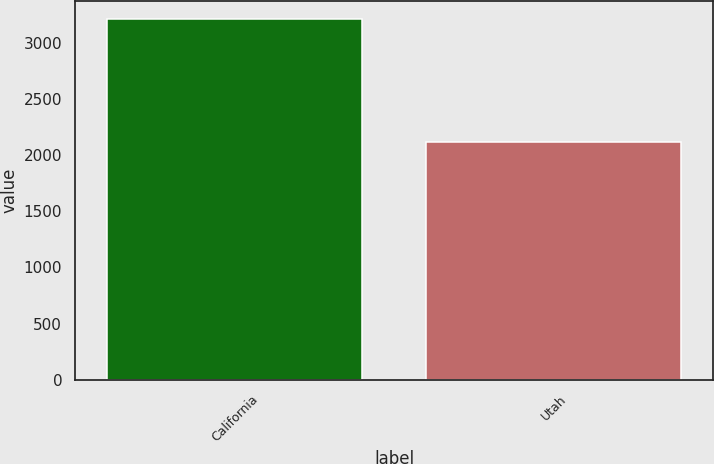<chart> <loc_0><loc_0><loc_500><loc_500><bar_chart><fcel>California<fcel>Utah<nl><fcel>3212<fcel>2117<nl></chart> 